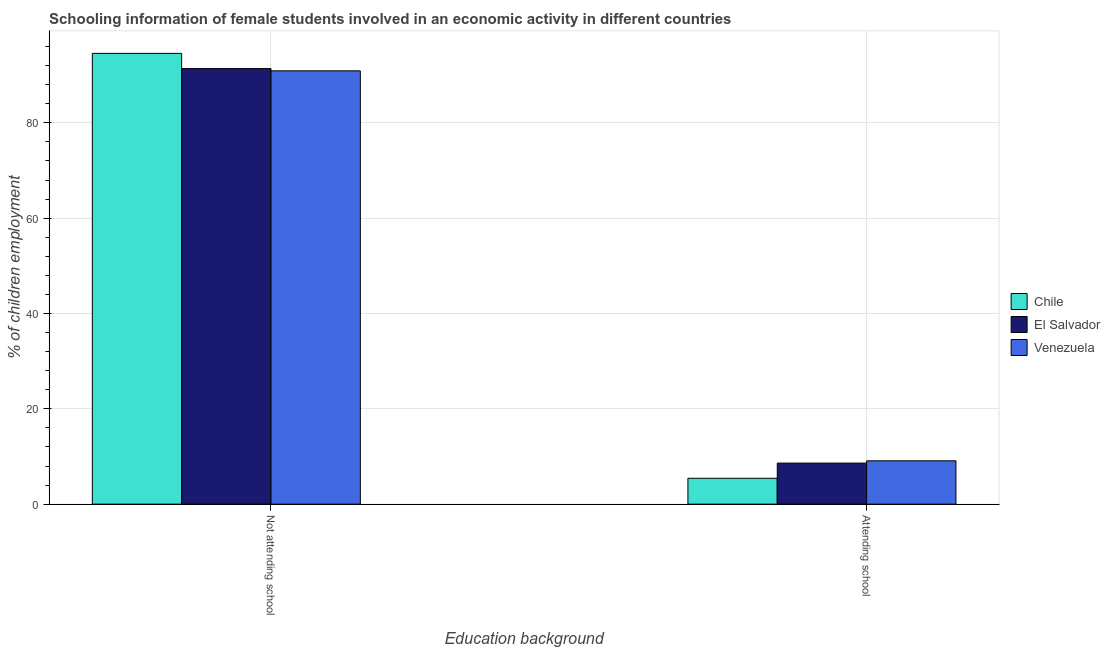How many different coloured bars are there?
Provide a succinct answer. 3. How many groups of bars are there?
Make the answer very short. 2. Are the number of bars per tick equal to the number of legend labels?
Make the answer very short. Yes. Are the number of bars on each tick of the X-axis equal?
Keep it short and to the point. Yes. How many bars are there on the 2nd tick from the right?
Provide a short and direct response. 3. What is the label of the 1st group of bars from the left?
Offer a terse response. Not attending school. What is the percentage of employed females who are attending school in El Salvador?
Your answer should be very brief. 8.62. Across all countries, what is the maximum percentage of employed females who are attending school?
Your response must be concise. 9.09. Across all countries, what is the minimum percentage of employed females who are attending school?
Offer a very short reply. 5.43. In which country was the percentage of employed females who are not attending school minimum?
Ensure brevity in your answer.  Venezuela. What is the total percentage of employed females who are attending school in the graph?
Give a very brief answer. 23.13. What is the difference between the percentage of employed females who are not attending school in Venezuela and that in Chile?
Ensure brevity in your answer.  -3.67. What is the difference between the percentage of employed females who are attending school in El Salvador and the percentage of employed females who are not attending school in Chile?
Your answer should be compact. -85.96. What is the average percentage of employed females who are not attending school per country?
Your response must be concise. 92.29. What is the difference between the percentage of employed females who are not attending school and percentage of employed females who are attending school in Venezuela?
Provide a succinct answer. 81.82. What is the ratio of the percentage of employed females who are not attending school in El Salvador to that in Chile?
Give a very brief answer. 0.97. In how many countries, is the percentage of employed females who are not attending school greater than the average percentage of employed females who are not attending school taken over all countries?
Your answer should be compact. 1. What does the 3rd bar from the left in Attending school represents?
Your response must be concise. Venezuela. What does the 2nd bar from the right in Attending school represents?
Ensure brevity in your answer.  El Salvador. Are all the bars in the graph horizontal?
Offer a terse response. No. How many countries are there in the graph?
Your response must be concise. 3. Does the graph contain any zero values?
Your answer should be very brief. No. What is the title of the graph?
Offer a very short reply. Schooling information of female students involved in an economic activity in different countries. What is the label or title of the X-axis?
Offer a terse response. Education background. What is the label or title of the Y-axis?
Ensure brevity in your answer.  % of children employment. What is the % of children employment of Chile in Not attending school?
Your answer should be compact. 94.57. What is the % of children employment in El Salvador in Not attending school?
Keep it short and to the point. 91.38. What is the % of children employment in Venezuela in Not attending school?
Provide a short and direct response. 90.91. What is the % of children employment of Chile in Attending school?
Your response must be concise. 5.43. What is the % of children employment in El Salvador in Attending school?
Make the answer very short. 8.62. What is the % of children employment in Venezuela in Attending school?
Provide a succinct answer. 9.09. Across all Education background, what is the maximum % of children employment of Chile?
Offer a terse response. 94.57. Across all Education background, what is the maximum % of children employment in El Salvador?
Make the answer very short. 91.38. Across all Education background, what is the maximum % of children employment of Venezuela?
Keep it short and to the point. 90.91. Across all Education background, what is the minimum % of children employment in Chile?
Ensure brevity in your answer.  5.43. Across all Education background, what is the minimum % of children employment in El Salvador?
Make the answer very short. 8.62. Across all Education background, what is the minimum % of children employment in Venezuela?
Your answer should be very brief. 9.09. What is the total % of children employment of El Salvador in the graph?
Your answer should be very brief. 100. What is the difference between the % of children employment in Chile in Not attending school and that in Attending school?
Make the answer very short. 89.15. What is the difference between the % of children employment of El Salvador in Not attending school and that in Attending school?
Offer a very short reply. 82.77. What is the difference between the % of children employment of Venezuela in Not attending school and that in Attending school?
Offer a very short reply. 81.82. What is the difference between the % of children employment in Chile in Not attending school and the % of children employment in El Salvador in Attending school?
Offer a very short reply. 85.96. What is the difference between the % of children employment in Chile in Not attending school and the % of children employment in Venezuela in Attending school?
Provide a succinct answer. 85.48. What is the difference between the % of children employment in El Salvador in Not attending school and the % of children employment in Venezuela in Attending school?
Make the answer very short. 82.29. What is the average % of children employment in El Salvador per Education background?
Provide a succinct answer. 50. What is the difference between the % of children employment of Chile and % of children employment of El Salvador in Not attending school?
Provide a short and direct response. 3.19. What is the difference between the % of children employment in Chile and % of children employment in Venezuela in Not attending school?
Give a very brief answer. 3.67. What is the difference between the % of children employment of El Salvador and % of children employment of Venezuela in Not attending school?
Offer a terse response. 0.47. What is the difference between the % of children employment of Chile and % of children employment of El Salvador in Attending school?
Offer a very short reply. -3.19. What is the difference between the % of children employment in Chile and % of children employment in Venezuela in Attending school?
Your answer should be very brief. -3.67. What is the difference between the % of children employment of El Salvador and % of children employment of Venezuela in Attending school?
Provide a succinct answer. -0.47. What is the ratio of the % of children employment in Chile in Not attending school to that in Attending school?
Ensure brevity in your answer.  17.43. What is the ratio of the % of children employment in El Salvador in Not attending school to that in Attending school?
Give a very brief answer. 10.6. What is the ratio of the % of children employment of Venezuela in Not attending school to that in Attending school?
Give a very brief answer. 10. What is the difference between the highest and the second highest % of children employment in Chile?
Offer a very short reply. 89.15. What is the difference between the highest and the second highest % of children employment of El Salvador?
Provide a succinct answer. 82.77. What is the difference between the highest and the second highest % of children employment in Venezuela?
Ensure brevity in your answer.  81.82. What is the difference between the highest and the lowest % of children employment in Chile?
Ensure brevity in your answer.  89.15. What is the difference between the highest and the lowest % of children employment in El Salvador?
Provide a short and direct response. 82.77. What is the difference between the highest and the lowest % of children employment in Venezuela?
Offer a terse response. 81.82. 